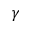Convert formula to latex. <formula><loc_0><loc_0><loc_500><loc_500>\gamma</formula> 